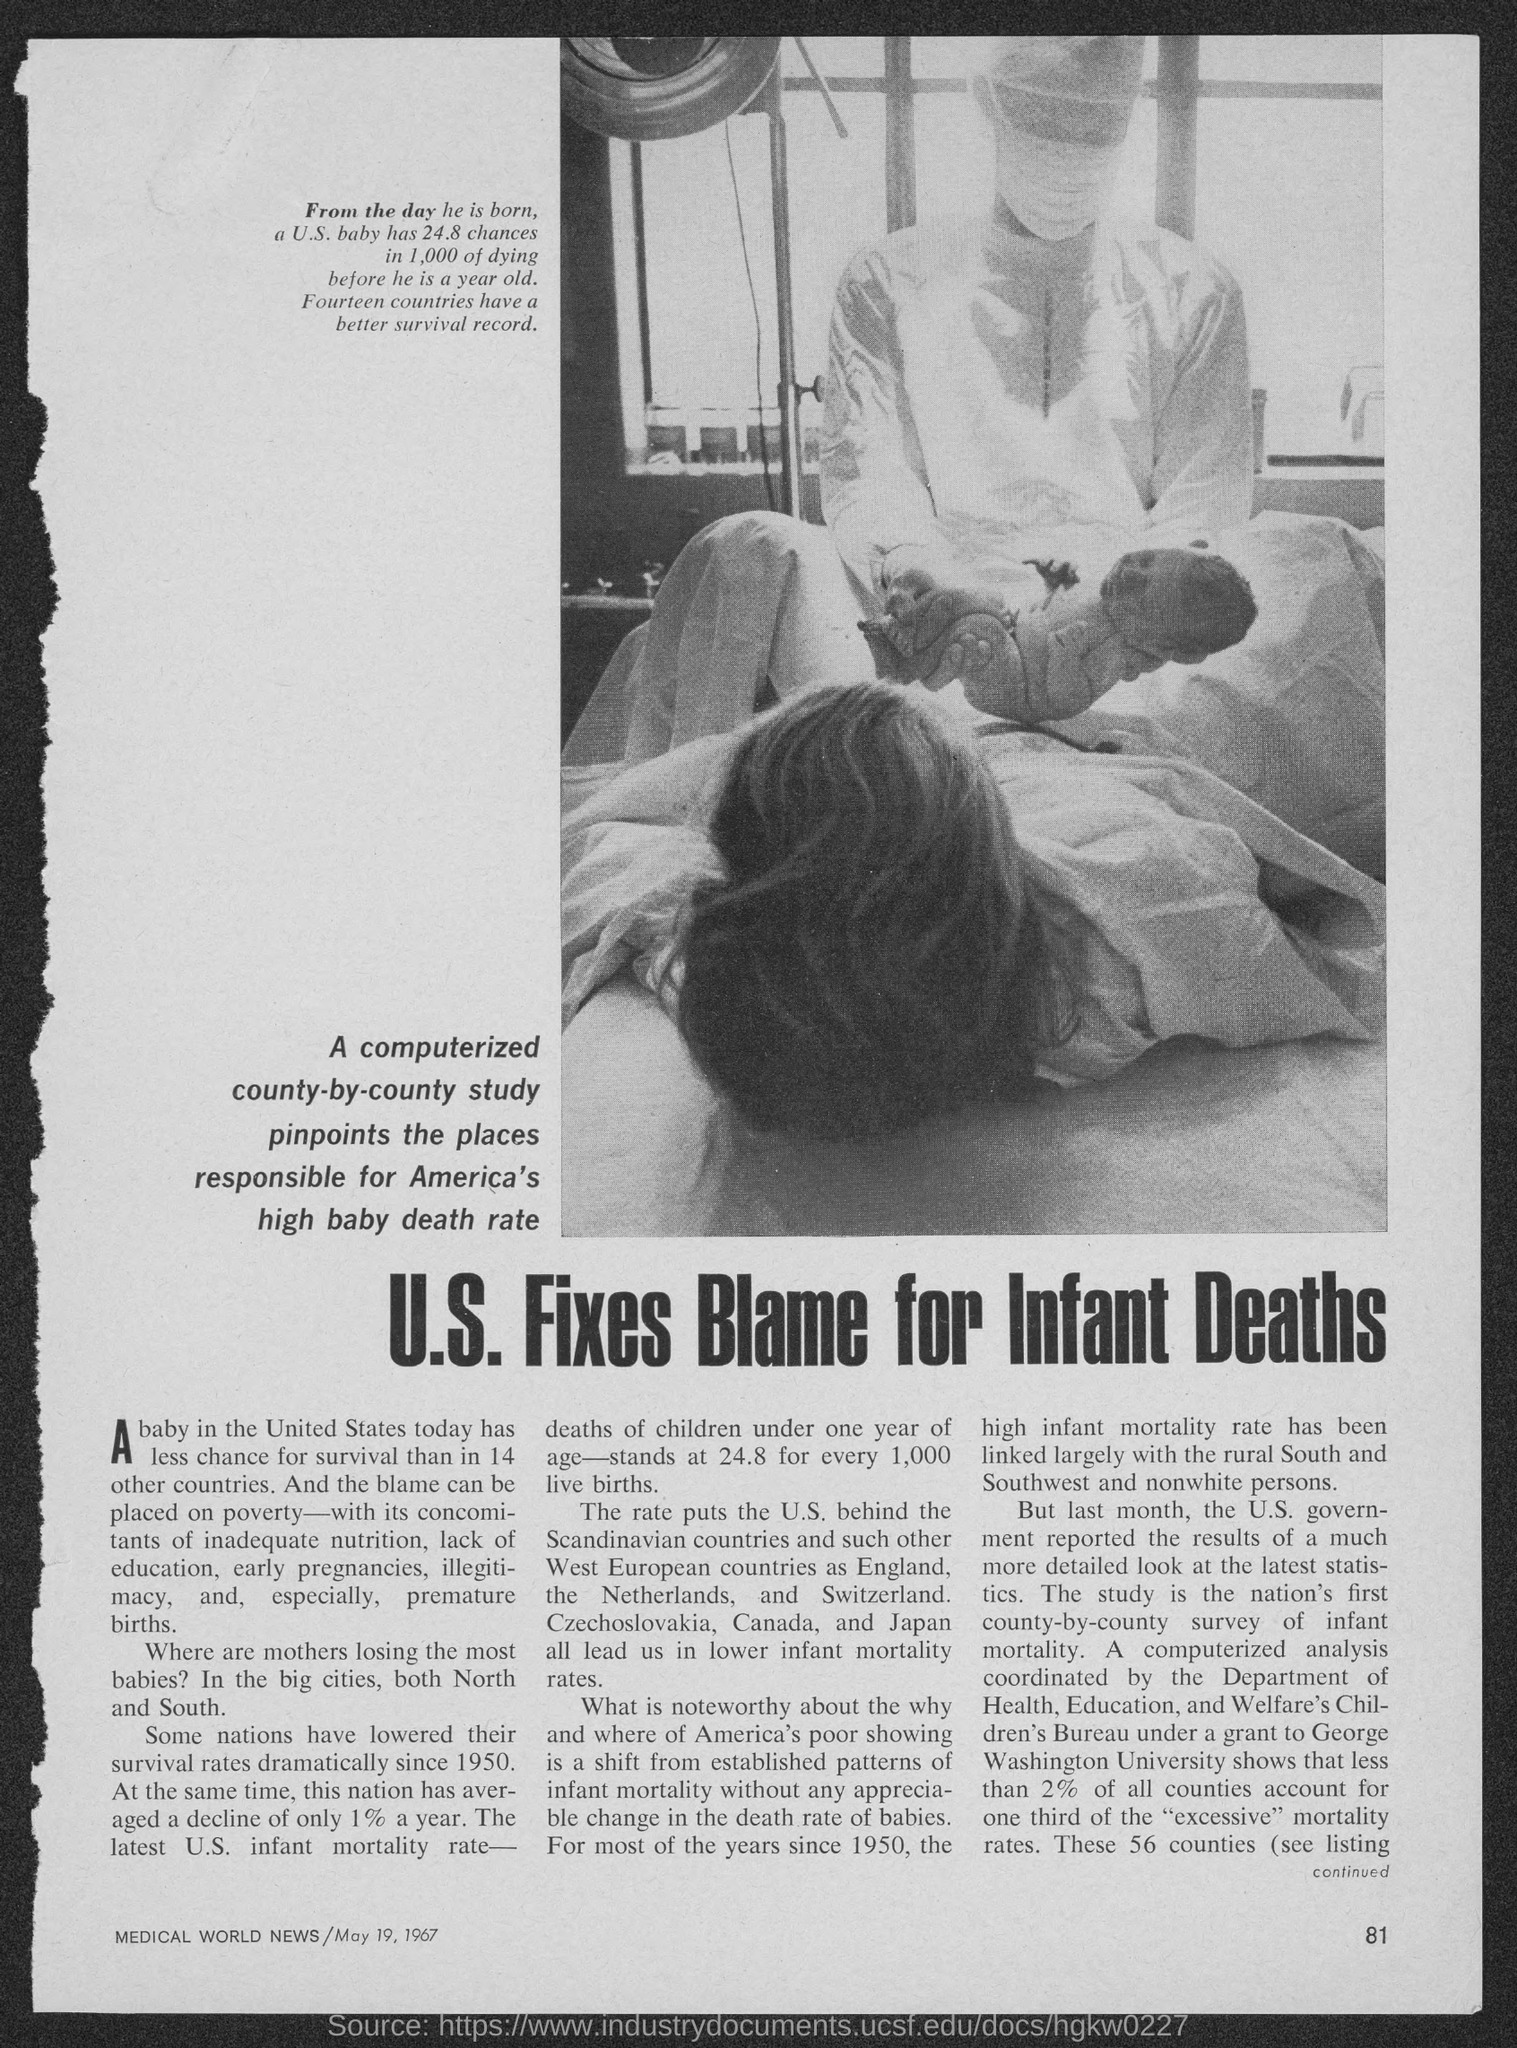Indicate a few pertinent items in this graphic. The date mentioned in the magazine is May 19, 1967. The headline of the news given is that the U.S. has fixed the blame for the deaths of infants. The page number mentioned in the magazine is 81. The name of the magazine is Medical World News. 